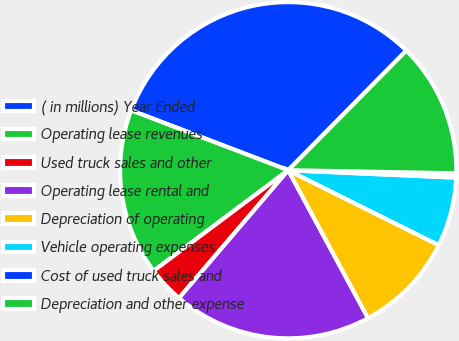Convert chart. <chart><loc_0><loc_0><loc_500><loc_500><pie_chart><fcel>( in millions) Year Ended<fcel>Operating lease revenues<fcel>Used truck sales and other<fcel>Operating lease rental and<fcel>Depreciation of operating<fcel>Vehicle operating expenses<fcel>Cost of used truck sales and<fcel>Depreciation and other expense<nl><fcel>31.6%<fcel>16.01%<fcel>3.53%<fcel>19.13%<fcel>9.77%<fcel>6.65%<fcel>0.41%<fcel>12.89%<nl></chart> 